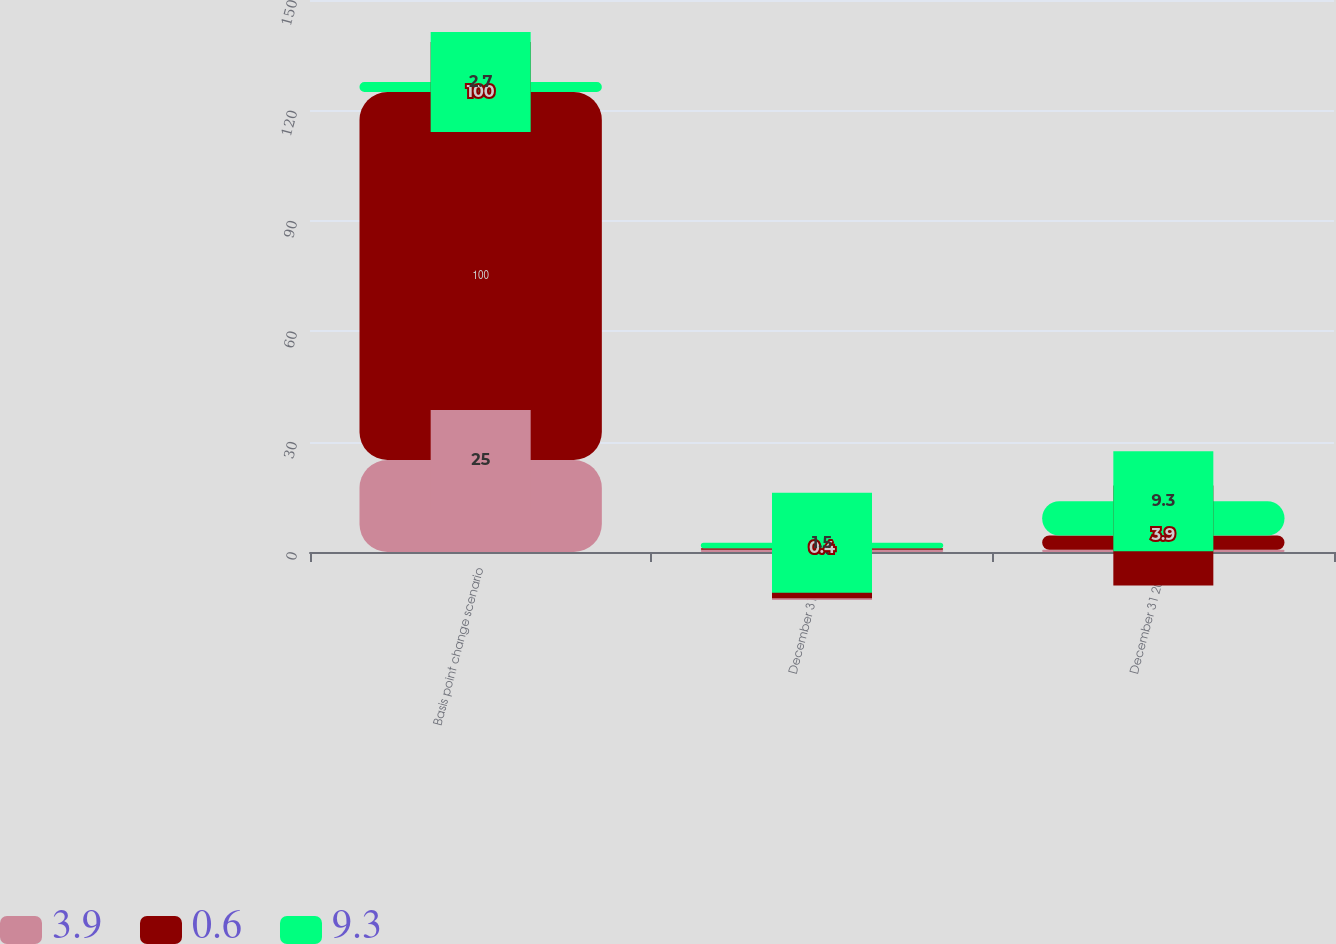Convert chart. <chart><loc_0><loc_0><loc_500><loc_500><stacked_bar_chart><ecel><fcel>Basis point change scenario<fcel>December 31 2014<fcel>December 31 2013<nl><fcel>3.9<fcel>25<fcel>0.6<fcel>0.6<nl><fcel>0.6<fcel>100<fcel>0.4<fcel>3.9<nl><fcel>9.3<fcel>2.7<fcel>1.5<fcel>9.3<nl></chart> 